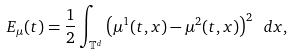<formula> <loc_0><loc_0><loc_500><loc_500>E _ { \mu } ( t ) = \frac { 1 } { 2 } \int _ { \mathbb { T } ^ { d } } \left ( \mu ^ { 1 } ( t , x ) - \mu ^ { 2 } ( t , x ) \right ) ^ { 2 } \ d x ,</formula> 